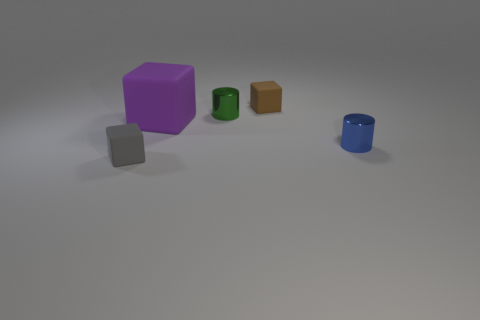Add 2 brown rubber things. How many objects exist? 7 Subtract all cylinders. How many objects are left? 3 Subtract all big rubber cubes. Subtract all small green cylinders. How many objects are left? 3 Add 3 small gray objects. How many small gray objects are left? 4 Add 3 small brown matte blocks. How many small brown matte blocks exist? 4 Subtract 0 cyan spheres. How many objects are left? 5 